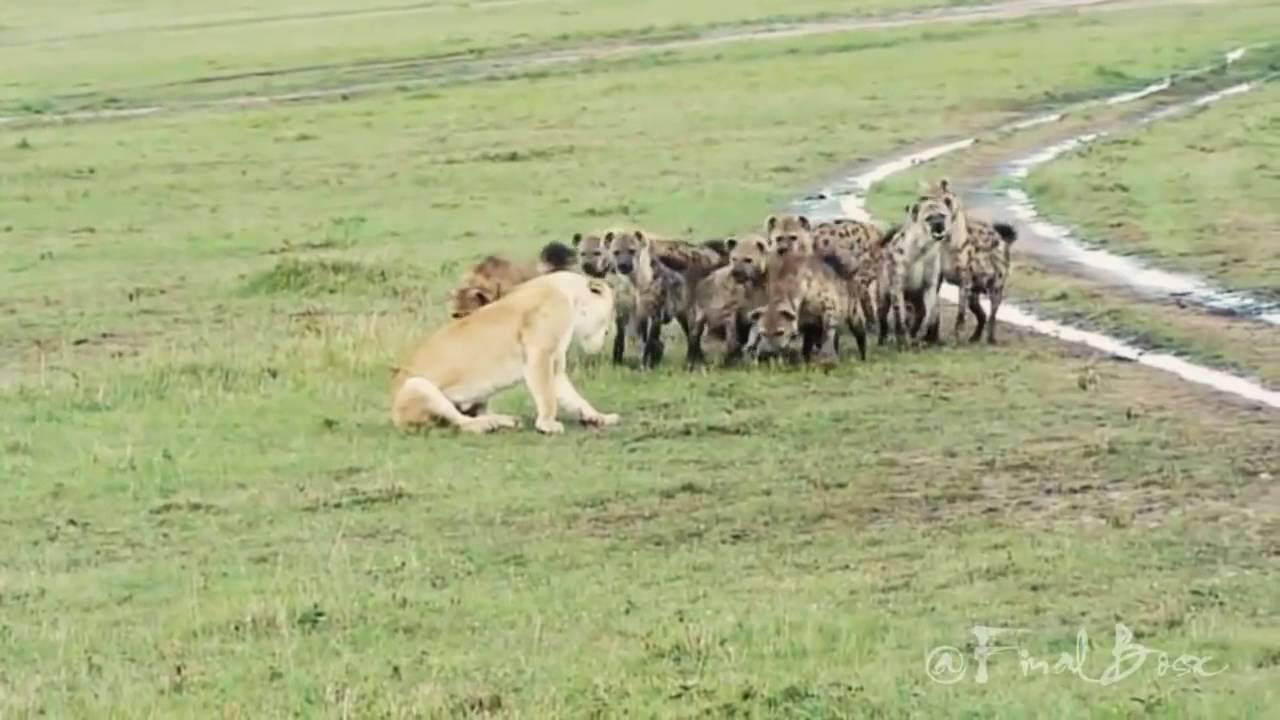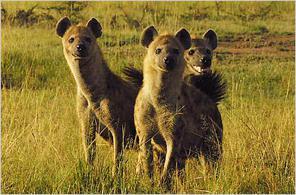The first image is the image on the left, the second image is the image on the right. For the images displayed, is the sentence "The image on the right shows no more than 5 cats." factually correct? Answer yes or no. Yes. The first image is the image on the left, the second image is the image on the right. For the images shown, is this caption "There are at least three hyenas facing forward in the grass." true? Answer yes or no. Yes. 